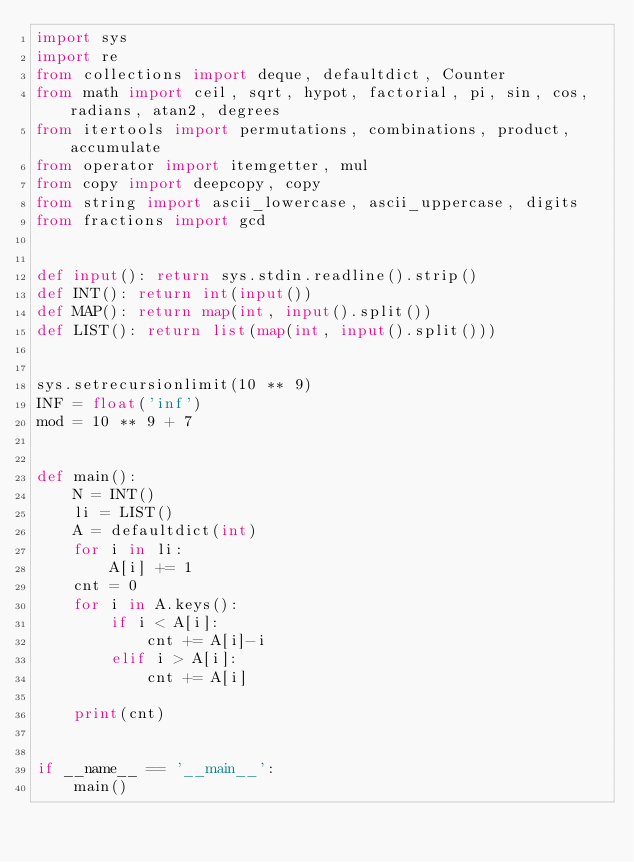Convert code to text. <code><loc_0><loc_0><loc_500><loc_500><_Python_>import sys
import re
from collections import deque, defaultdict, Counter
from math import ceil, sqrt, hypot, factorial, pi, sin, cos, radians, atan2, degrees
from itertools import permutations, combinations, product, accumulate
from operator import itemgetter, mul
from copy import deepcopy, copy
from string import ascii_lowercase, ascii_uppercase, digits
from fractions import gcd


def input(): return sys.stdin.readline().strip()
def INT(): return int(input())
def MAP(): return map(int, input().split())
def LIST(): return list(map(int, input().split()))


sys.setrecursionlimit(10 ** 9)
INF = float('inf')
mod = 10 ** 9 + 7


def main():
    N = INT()
    li = LIST()
    A = defaultdict(int)
    for i in li:
        A[i] += 1
    cnt = 0
    for i in A.keys():
        if i < A[i]:
            cnt += A[i]-i
        elif i > A[i]:
            cnt += A[i]

    print(cnt)


if __name__ == '__main__':
    main()
</code> 